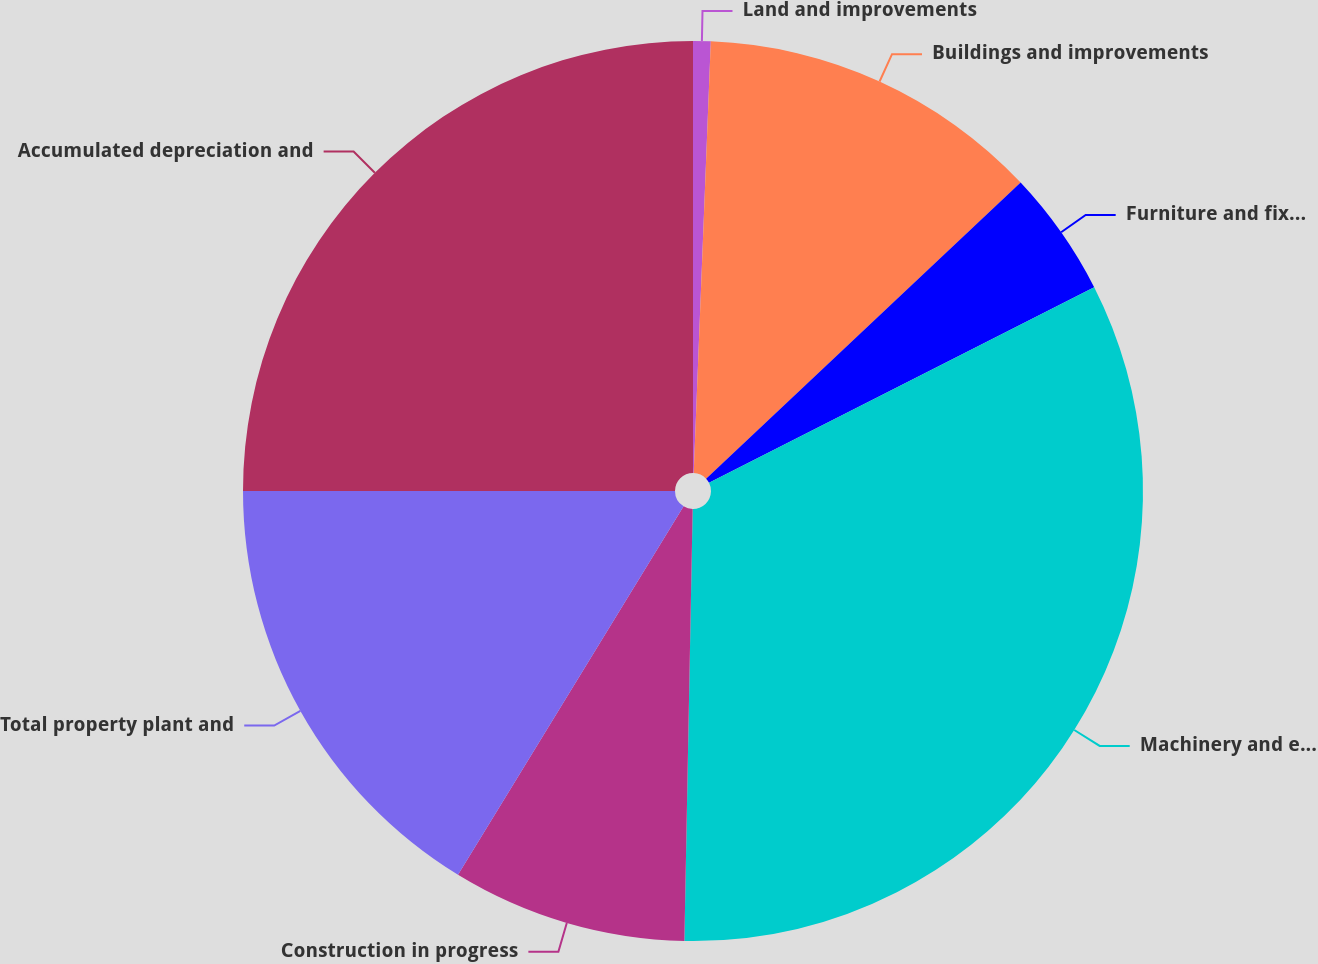<chart> <loc_0><loc_0><loc_500><loc_500><pie_chart><fcel>Land and improvements<fcel>Buildings and improvements<fcel>Furniture and fixtures<fcel>Machinery and equipment<fcel>Construction in progress<fcel>Total property plant and<fcel>Accumulated depreciation and<nl><fcel>0.63%<fcel>12.35%<fcel>4.54%<fcel>32.79%<fcel>8.44%<fcel>16.26%<fcel>25.0%<nl></chart> 